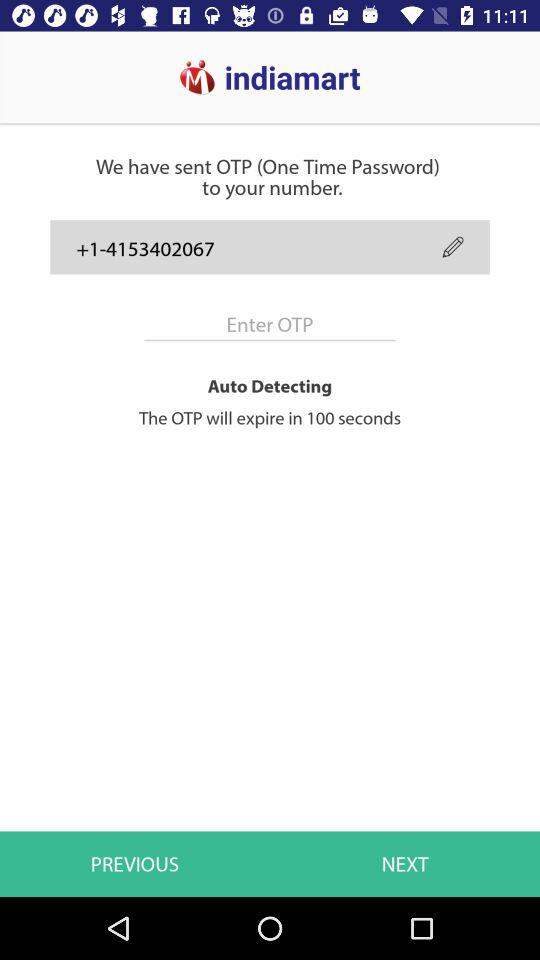When will the one-time password expire? The one-time password will expire in 100 seconds. 